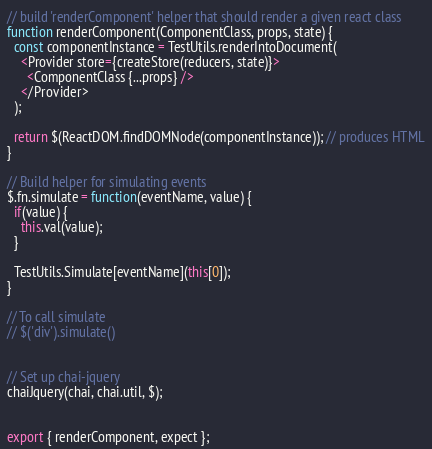Convert code to text. <code><loc_0><loc_0><loc_500><loc_500><_JavaScript_>
// build 'renderComponent' helper that should render a given react class
function renderComponent(ComponentClass, props, state) {
  const componentInstance = TestUtils.renderIntoDocument(
    <Provider store={createStore(reducers, state)}>
      <ComponentClass {...props} />
    </Provider>
  );

  return $(ReactDOM.findDOMNode(componentInstance)); // produces HTML
}

// Build helper for simulating events
$.fn.simulate = function(eventName, value) {
  if(value) {
    this.val(value);
  }

  TestUtils.Simulate[eventName](this[0]);
}

// To call simulate
// $('div').simulate()


// Set up chai-jquery
chaiJquery(chai, chai.util, $);


export { renderComponent, expect };
</code> 